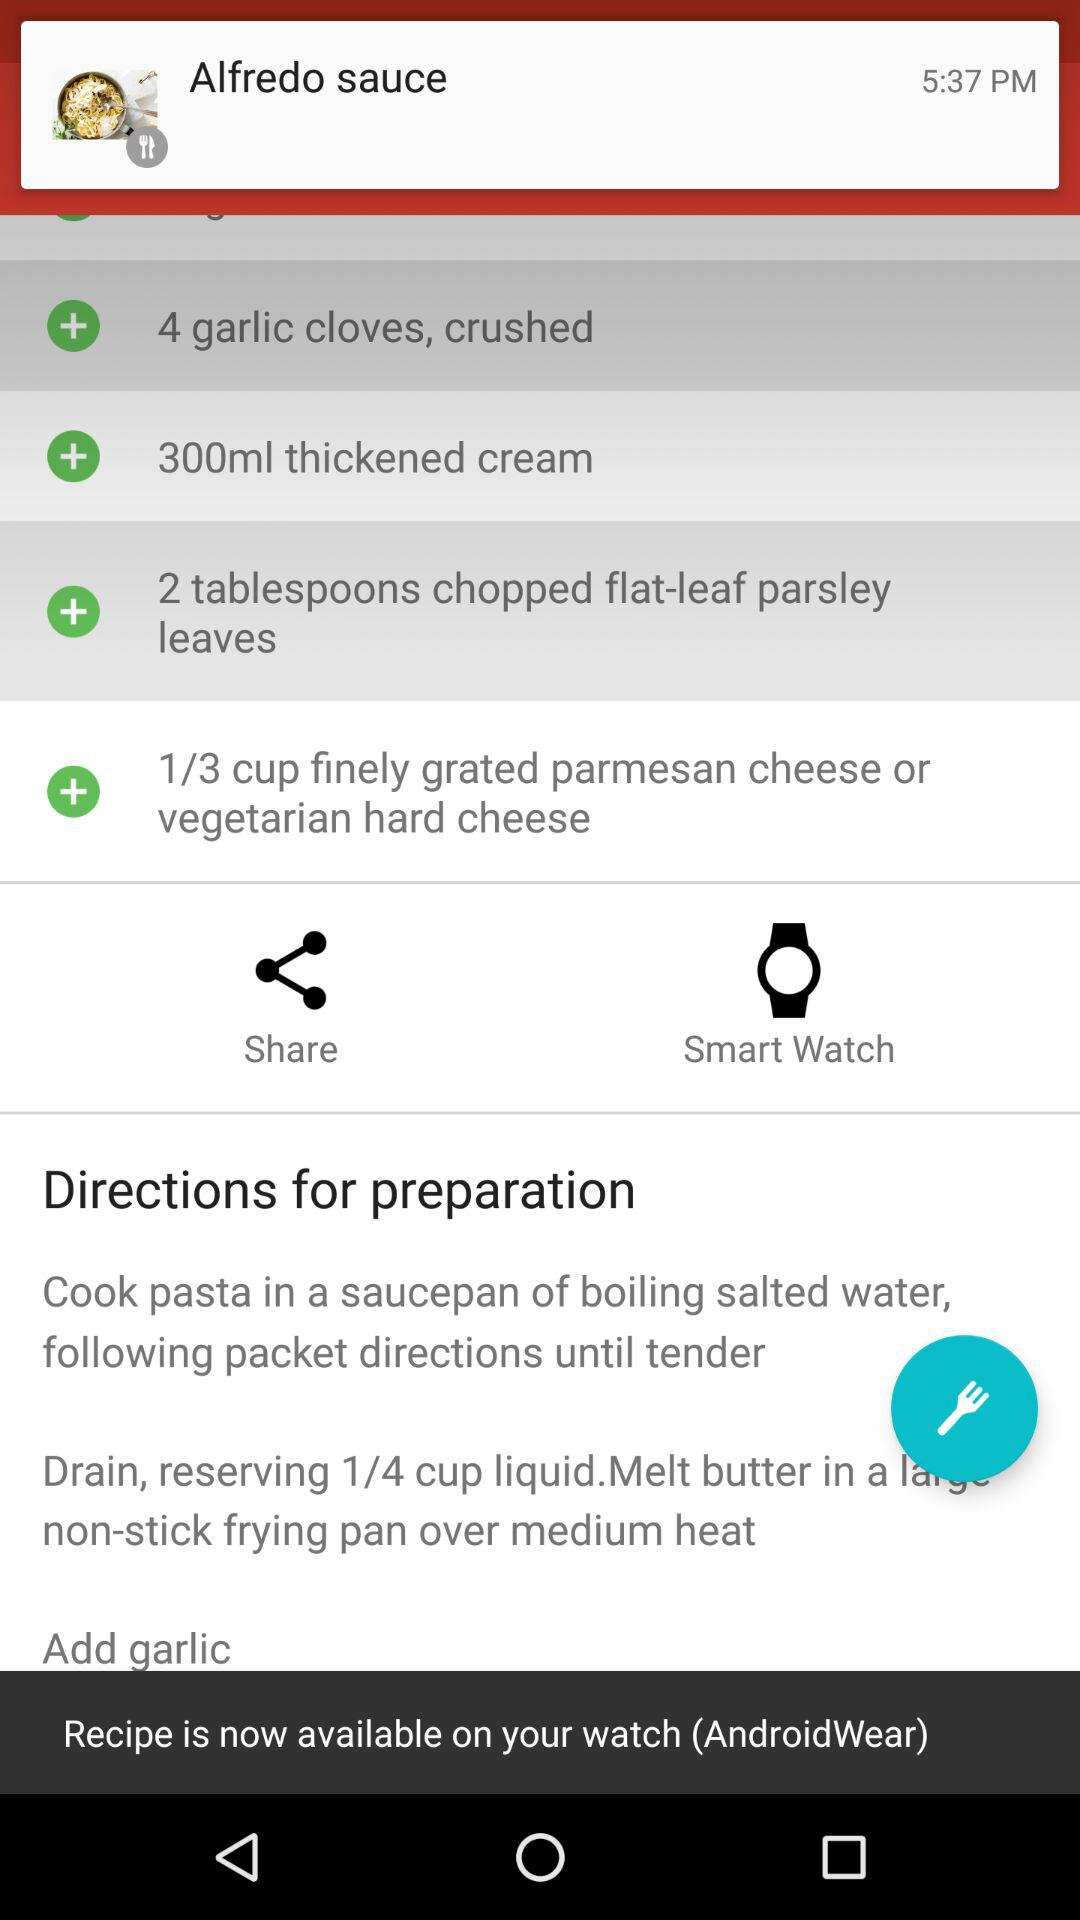How many tablespoons of chopped flat-leaf parsley leaves are required? There are 2 tablespoons of chopped flat-leaf parsley leaves required. 